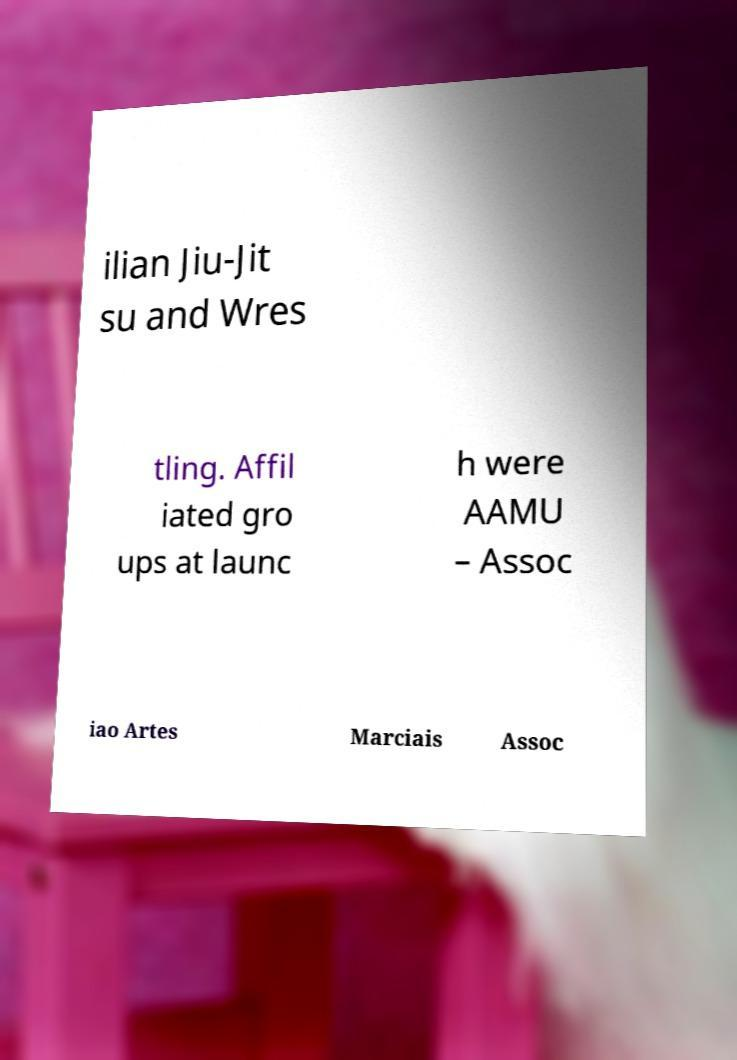What messages or text are displayed in this image? I need them in a readable, typed format. ilian Jiu-Jit su and Wres tling. Affil iated gro ups at launc h were AAMU – Assoc iao Artes Marciais Assoc 